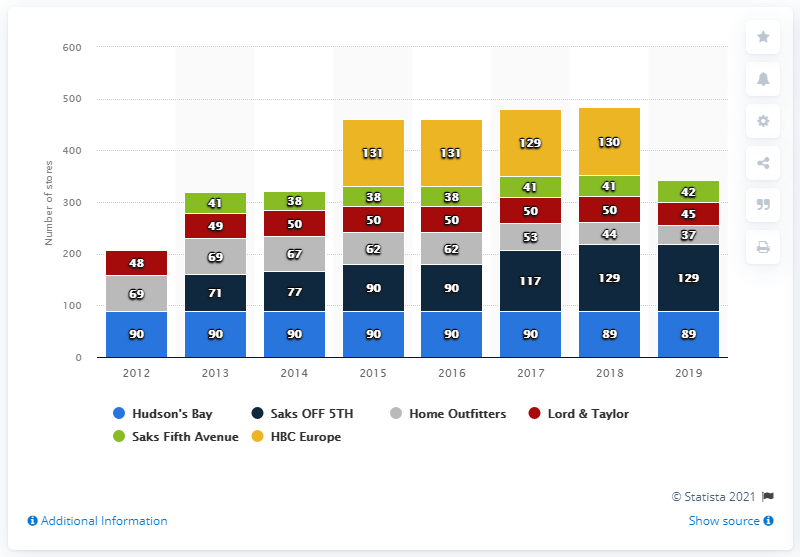List a handful of essential elements in this visual. In 2017 and 2018, the average number of Hudson's Bay Company stores was 89.5. As of February 2, 2019, Saks OFF 5TH had a total of 129 locations. Saks OFF 5TH had the largest number of stores among all brands. In 2019, the total number of Hudson's Bay Company stores was 89. 